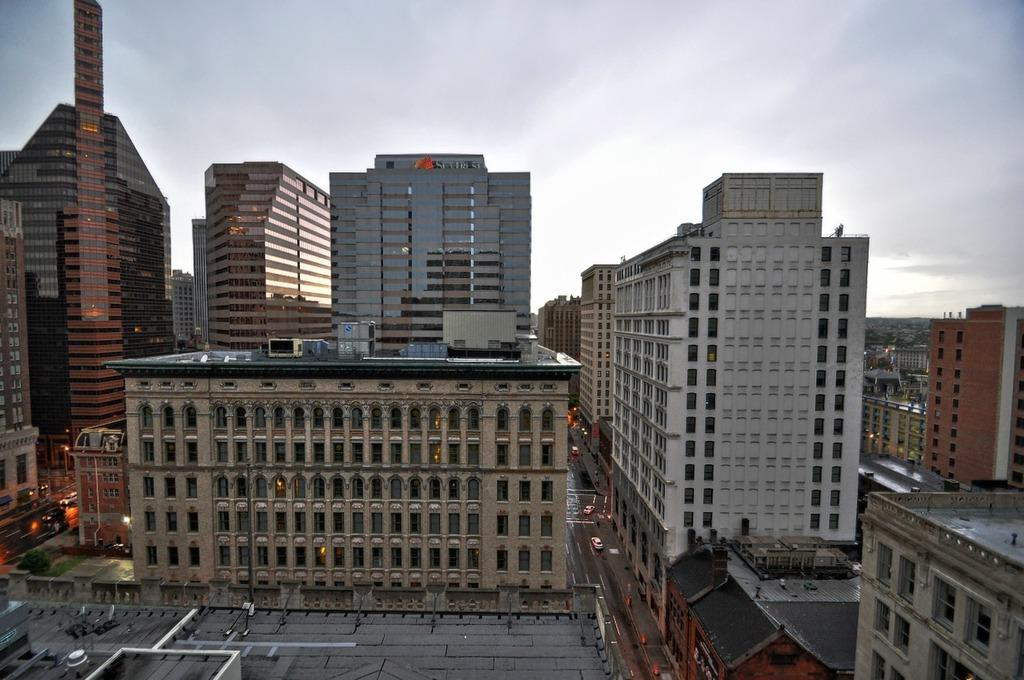What type of structures are visible in the image? There are buildings and skyscrapers in the image. What else can be seen in the image besides the structures? There are roads in the image. What is happening on the roads? Vehicles are moving on the roads. What is visible at the top of the image? The sky is visible at the top of the image. Where is the cactus located in the image? There is no cactus present in the image. What type of vegetable is being harvested in the image? There is no vegetable being harvested in the image; it features buildings, skyscrapers, roads, and vehicles. 